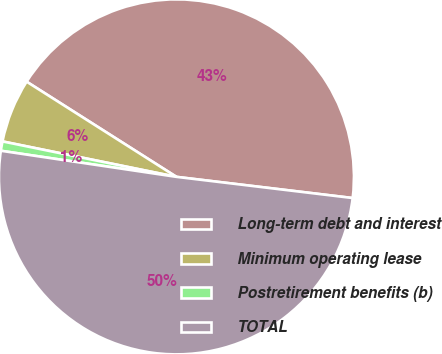Convert chart. <chart><loc_0><loc_0><loc_500><loc_500><pie_chart><fcel>Long-term debt and interest<fcel>Minimum operating lease<fcel>Postretirement benefits (b)<fcel>TOTAL<nl><fcel>42.9%<fcel>5.81%<fcel>0.85%<fcel>50.45%<nl></chart> 